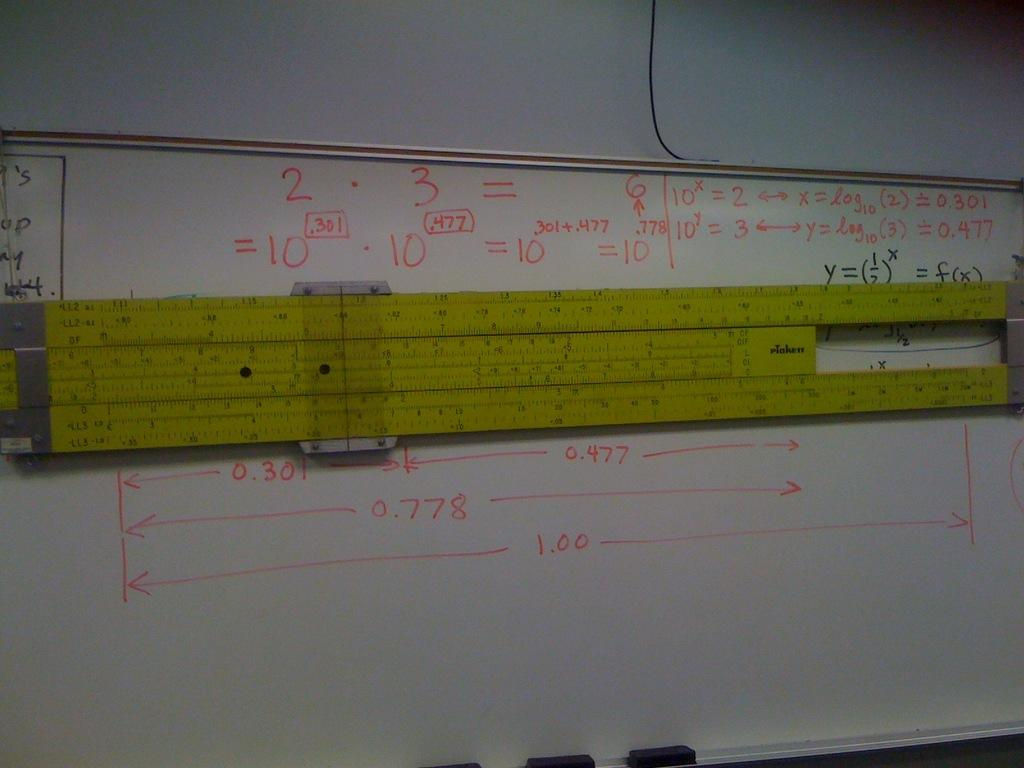Provide a one-sentence caption for the provided image. a white board with the number 3 on it. 